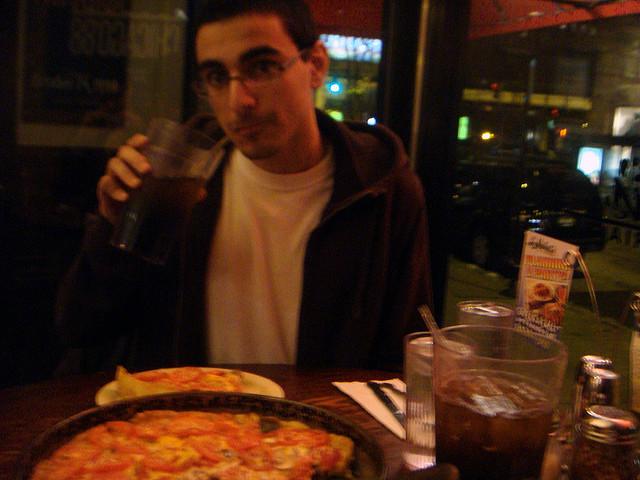What is on the table?
Answer briefly. Pizza. Where are the food?
Keep it brief. Table. Is he thirsty?
Answer briefly. Yes. What is the man doing?
Answer briefly. Drinking. What is he holding?
Be succinct. Cup. 